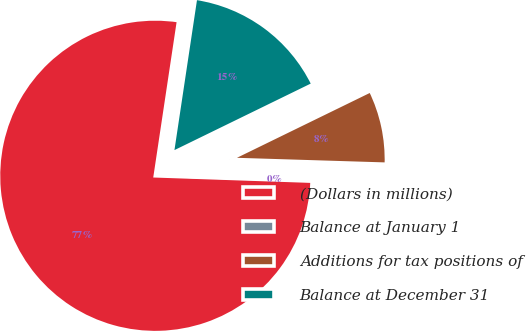Convert chart to OTSL. <chart><loc_0><loc_0><loc_500><loc_500><pie_chart><fcel>(Dollars in millions)<fcel>Balance at January 1<fcel>Additions for tax positions of<fcel>Balance at December 31<nl><fcel>76.83%<fcel>0.05%<fcel>7.72%<fcel>15.4%<nl></chart> 